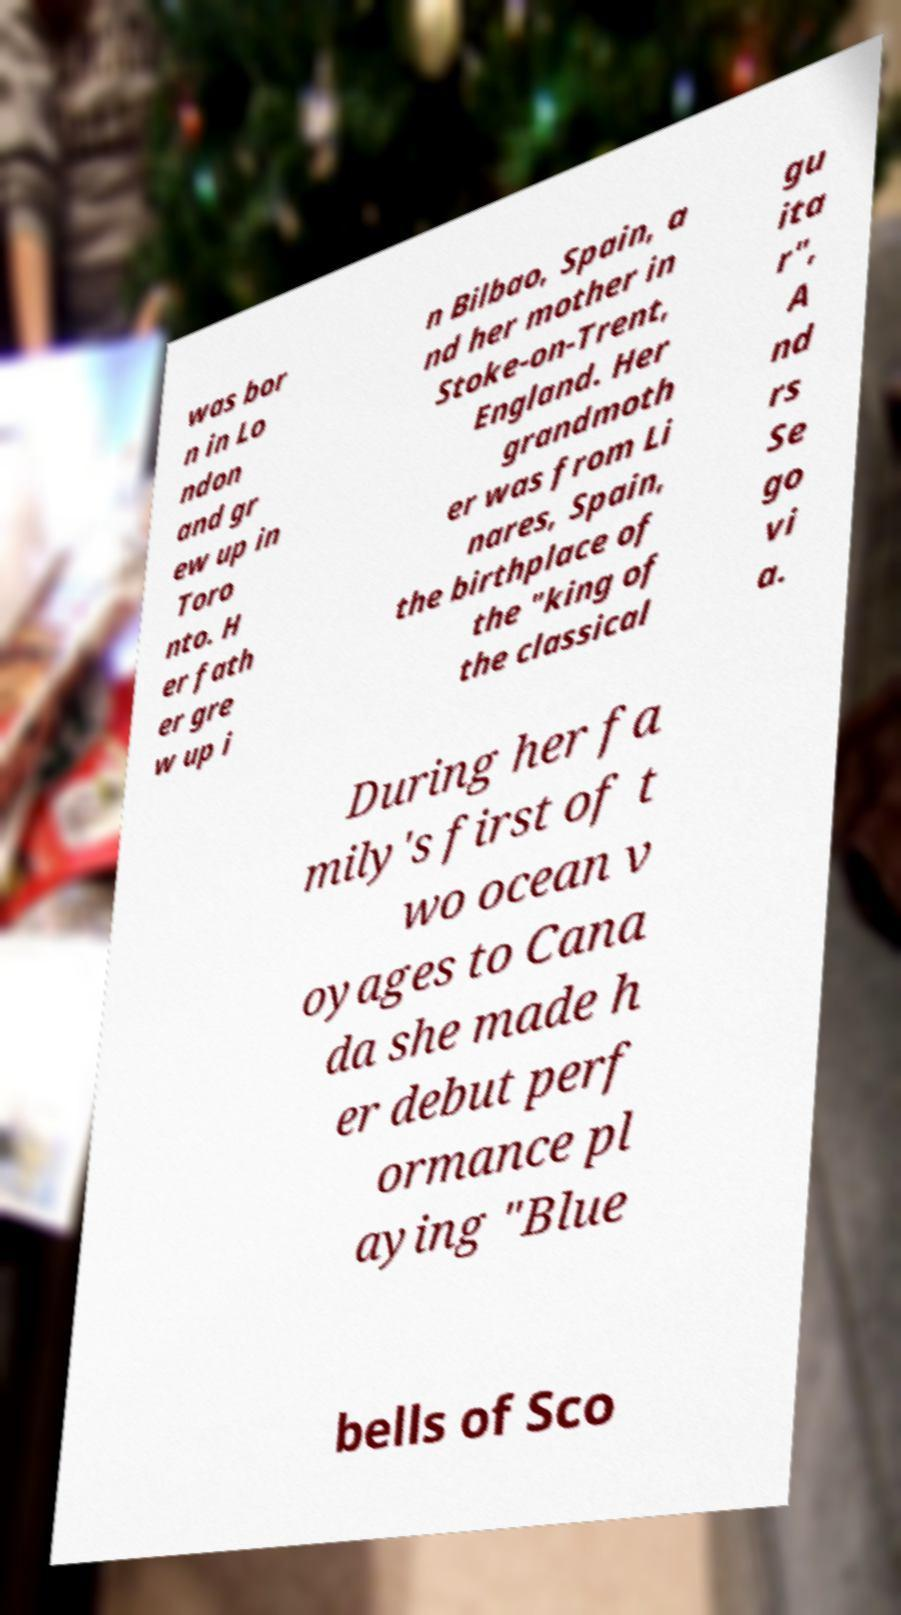Please read and relay the text visible in this image. What does it say? was bor n in Lo ndon and gr ew up in Toro nto. H er fath er gre w up i n Bilbao, Spain, a nd her mother in Stoke-on-Trent, England. Her grandmoth er was from Li nares, Spain, the birthplace of the "king of the classical gu ita r", A nd rs Se go vi a. During her fa mily's first of t wo ocean v oyages to Cana da she made h er debut perf ormance pl aying "Blue bells of Sco 